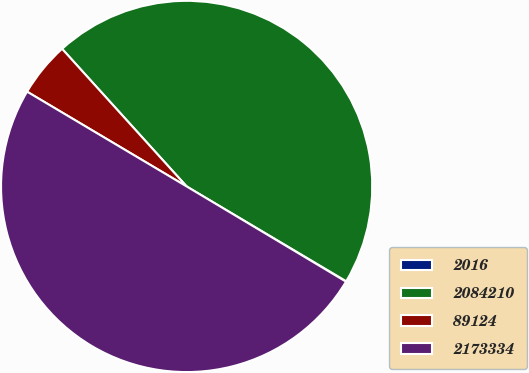Convert chart. <chart><loc_0><loc_0><loc_500><loc_500><pie_chart><fcel>2016<fcel>2084210<fcel>89124<fcel>2173334<nl><fcel>0.04%<fcel>45.24%<fcel>4.76%<fcel>49.96%<nl></chart> 